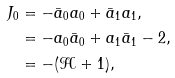<formula> <loc_0><loc_0><loc_500><loc_500>J _ { 0 } & = - { \bar { a } } _ { 0 } a _ { 0 } + { \bar { a } } _ { 1 } a _ { 1 } , \\ & = - a _ { 0 } { \bar { a } } _ { 0 } + a _ { 1 } { \bar { a } } _ { 1 } - 2 , \\ & = - ( { \mathcal { H } } + 1 ) ,</formula> 